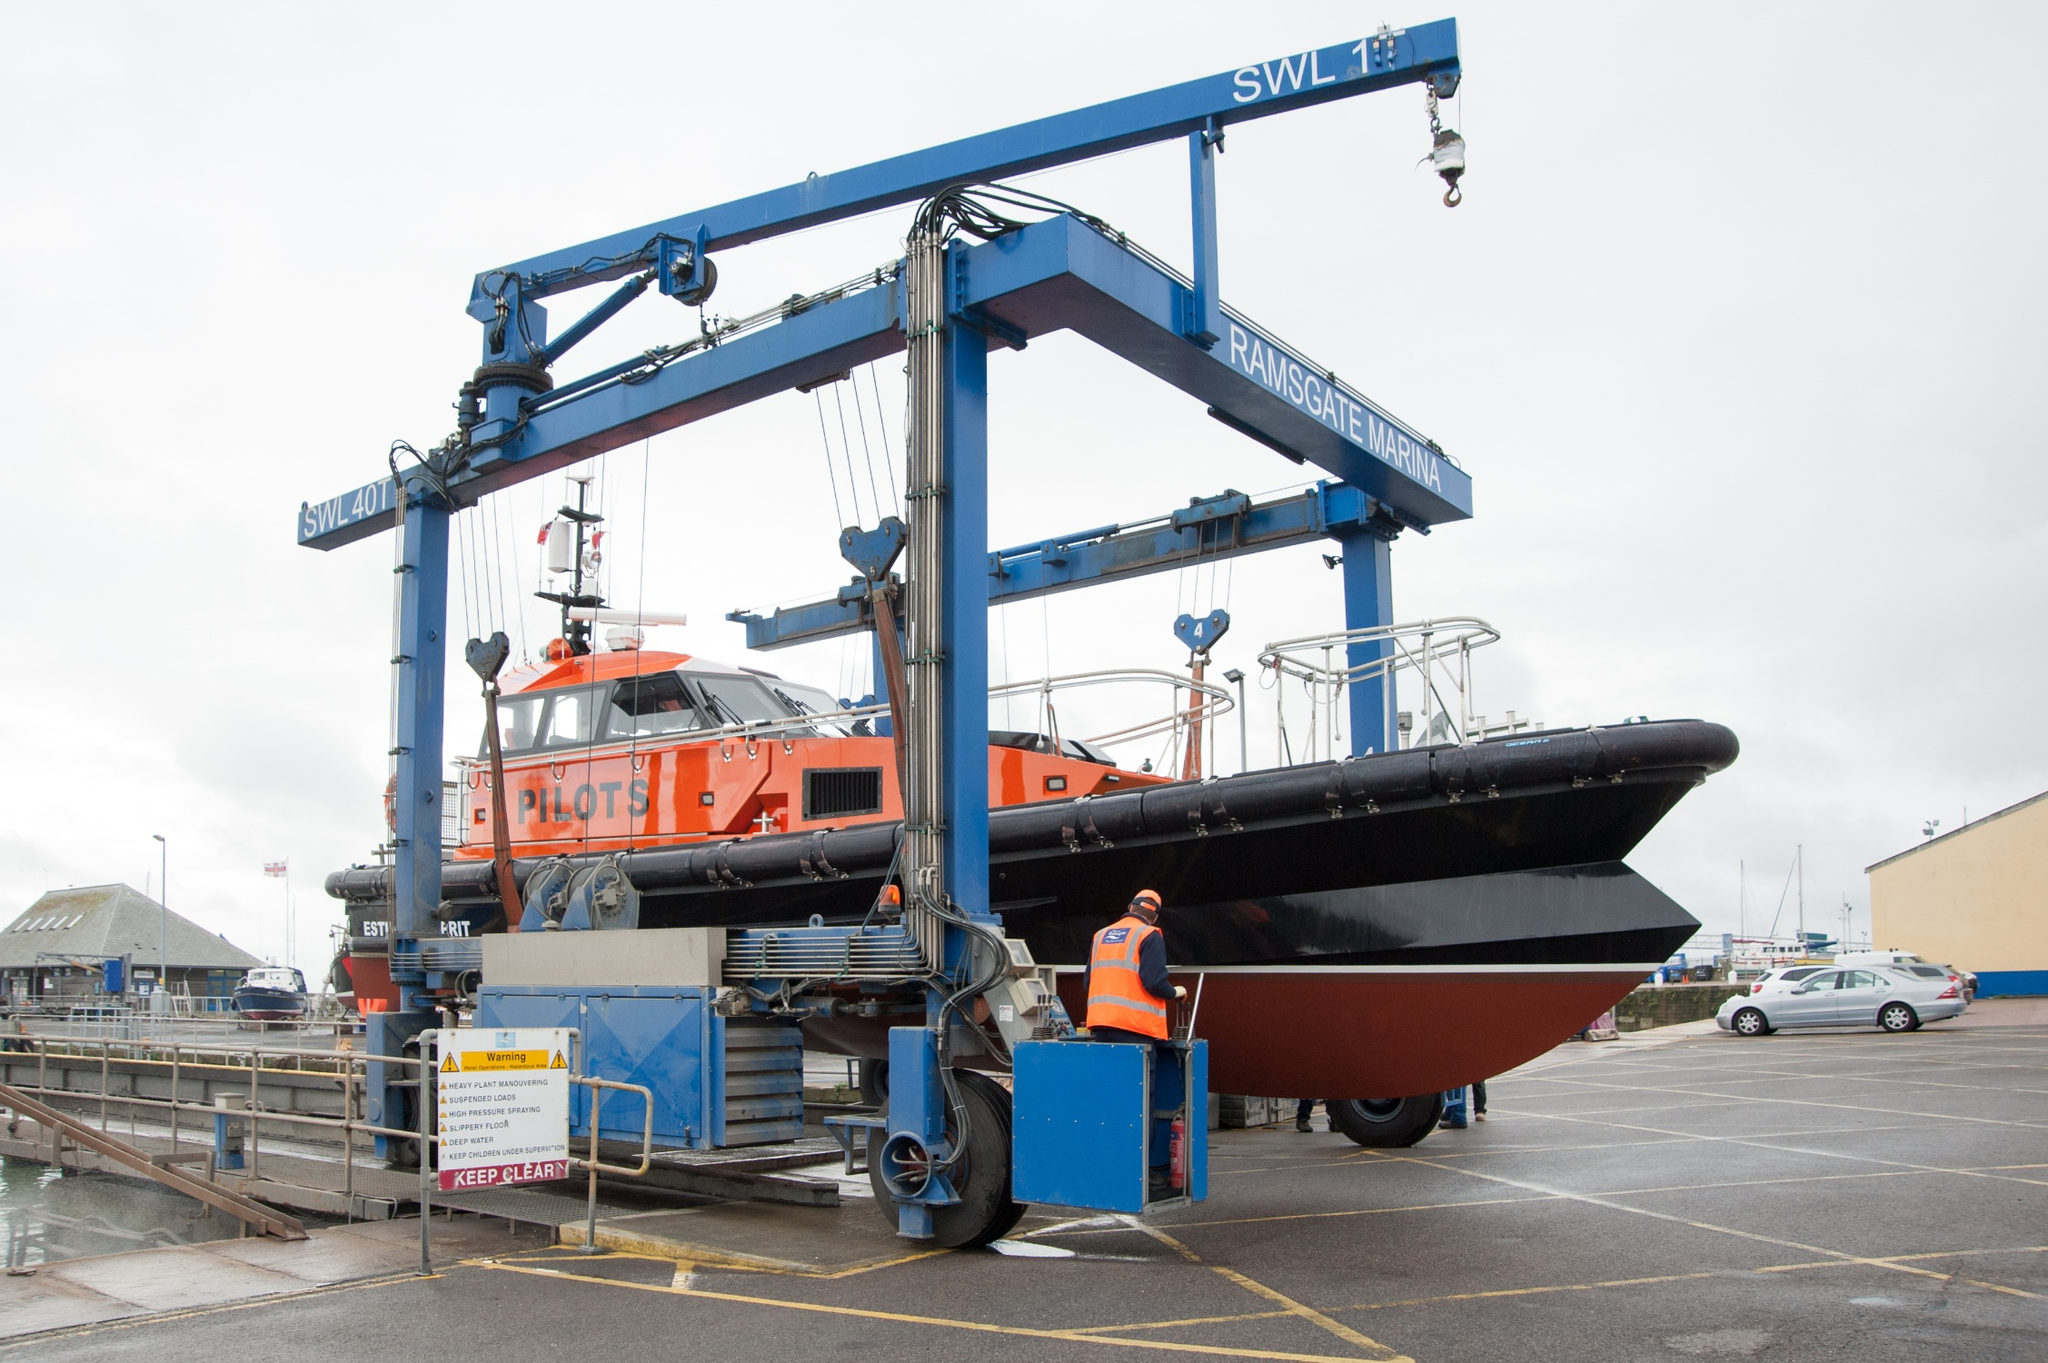Can you tell me more about the pilot boat in the picture? Certainly! The pilot boat featured in the image is designed for maritime pilot transfer, which is key to navigating larger ships through challenging or crowded waters. The boat's robust structure and vibrant orange color aid in visibility during these operations. It's equipped with essential safety and navigation equipment, as indicated by the visible antennas and radar instruments on its roof. Such boats play a crucial role in maritime safety, helping guide vessels safely to their berths or out to open sea. 